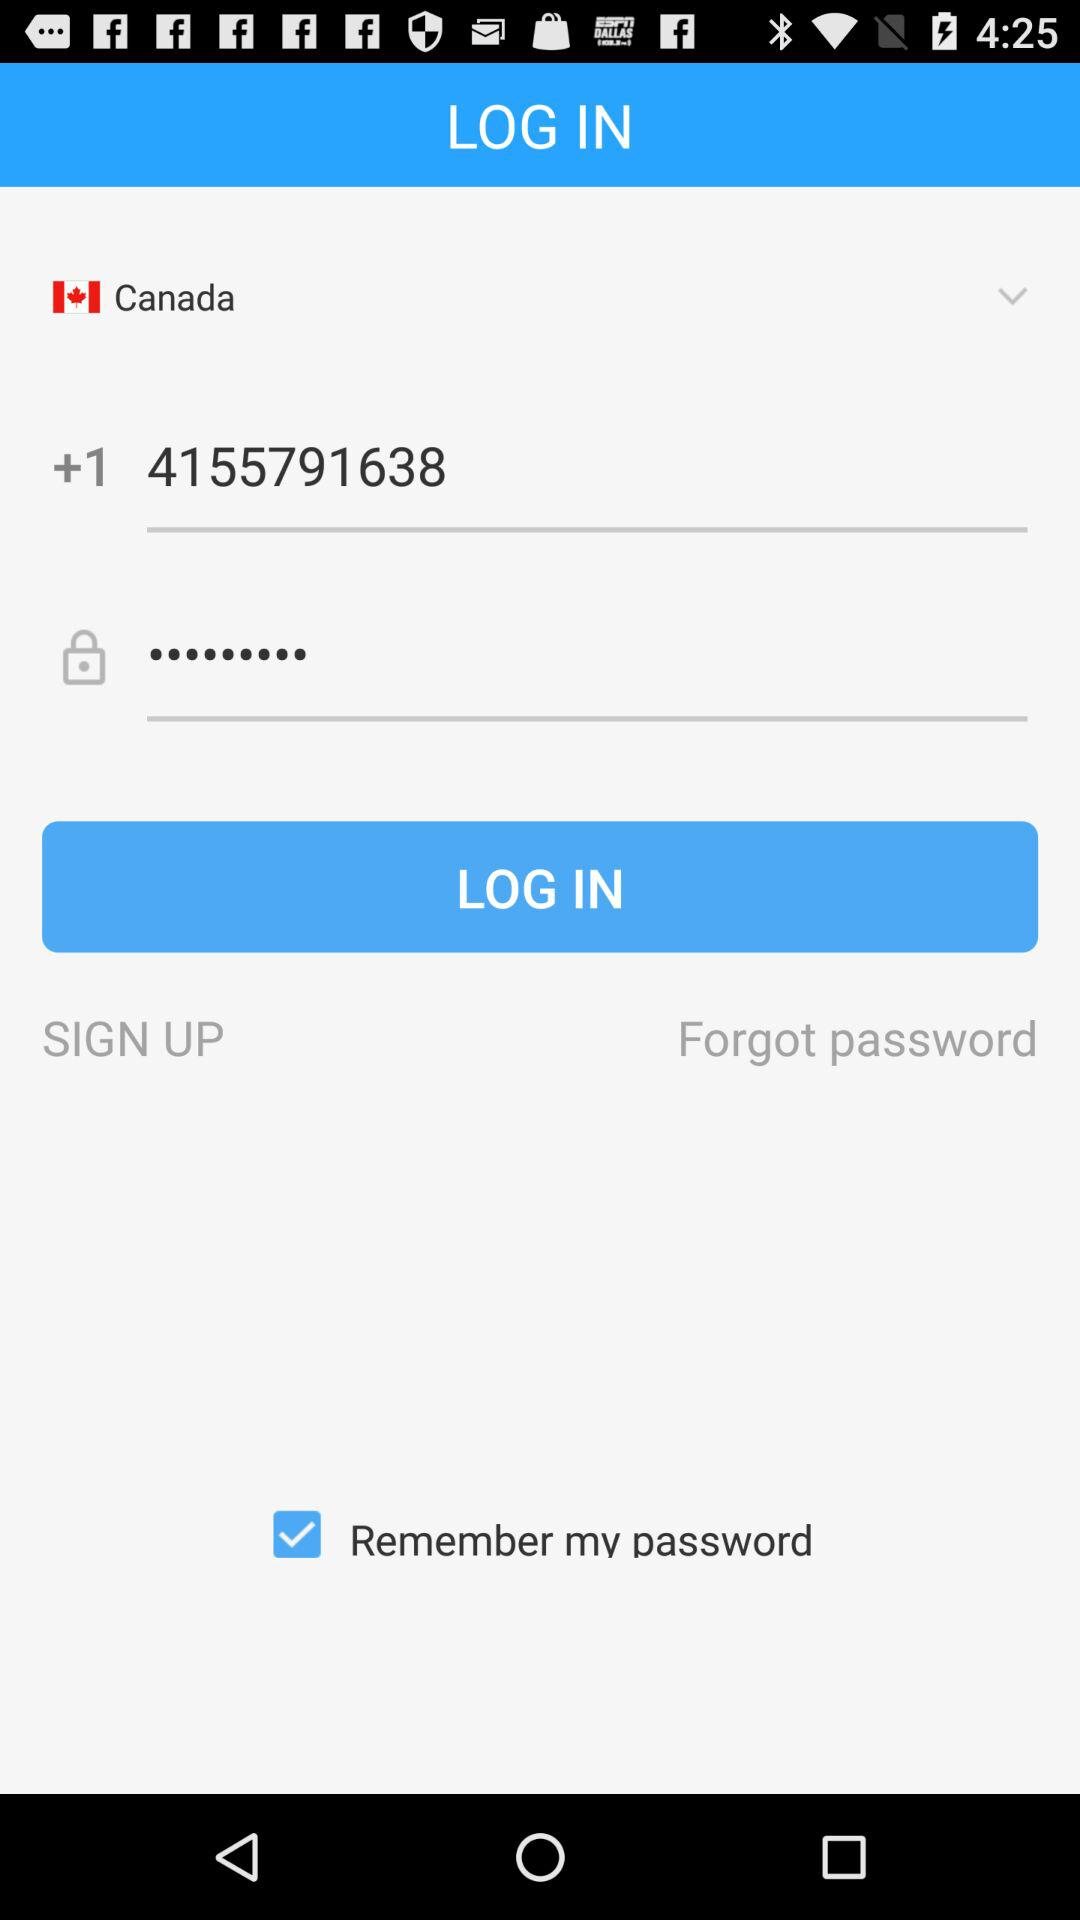Which country has been selected? The selected country is Canada. 